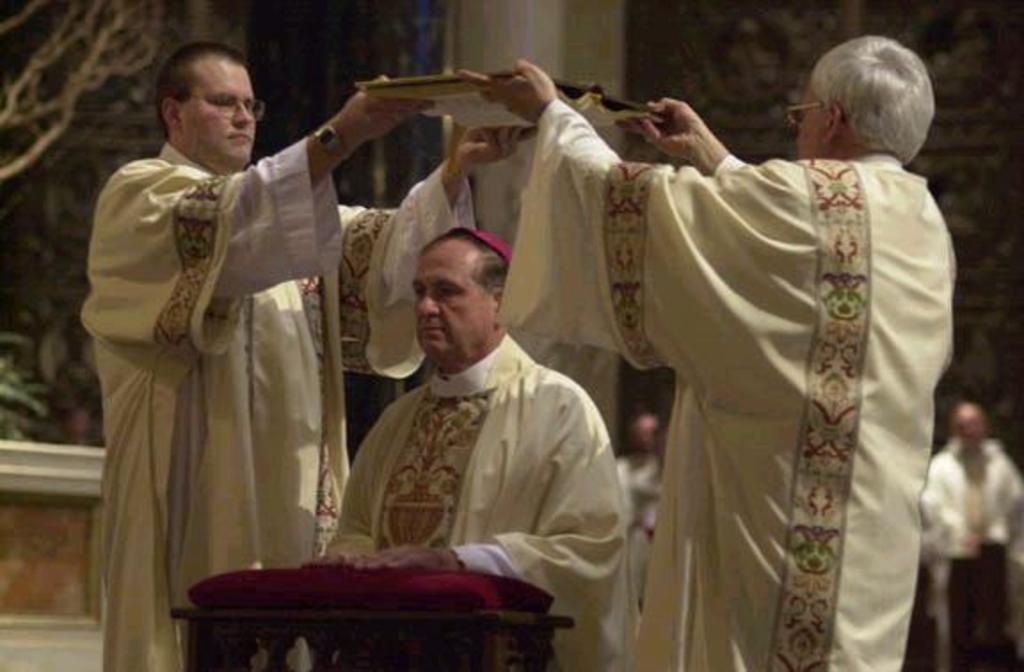Could you give a brief overview of what you see in this image? In the image the ordination of bishop is being performed and in the background there are some other people they are blurred. 